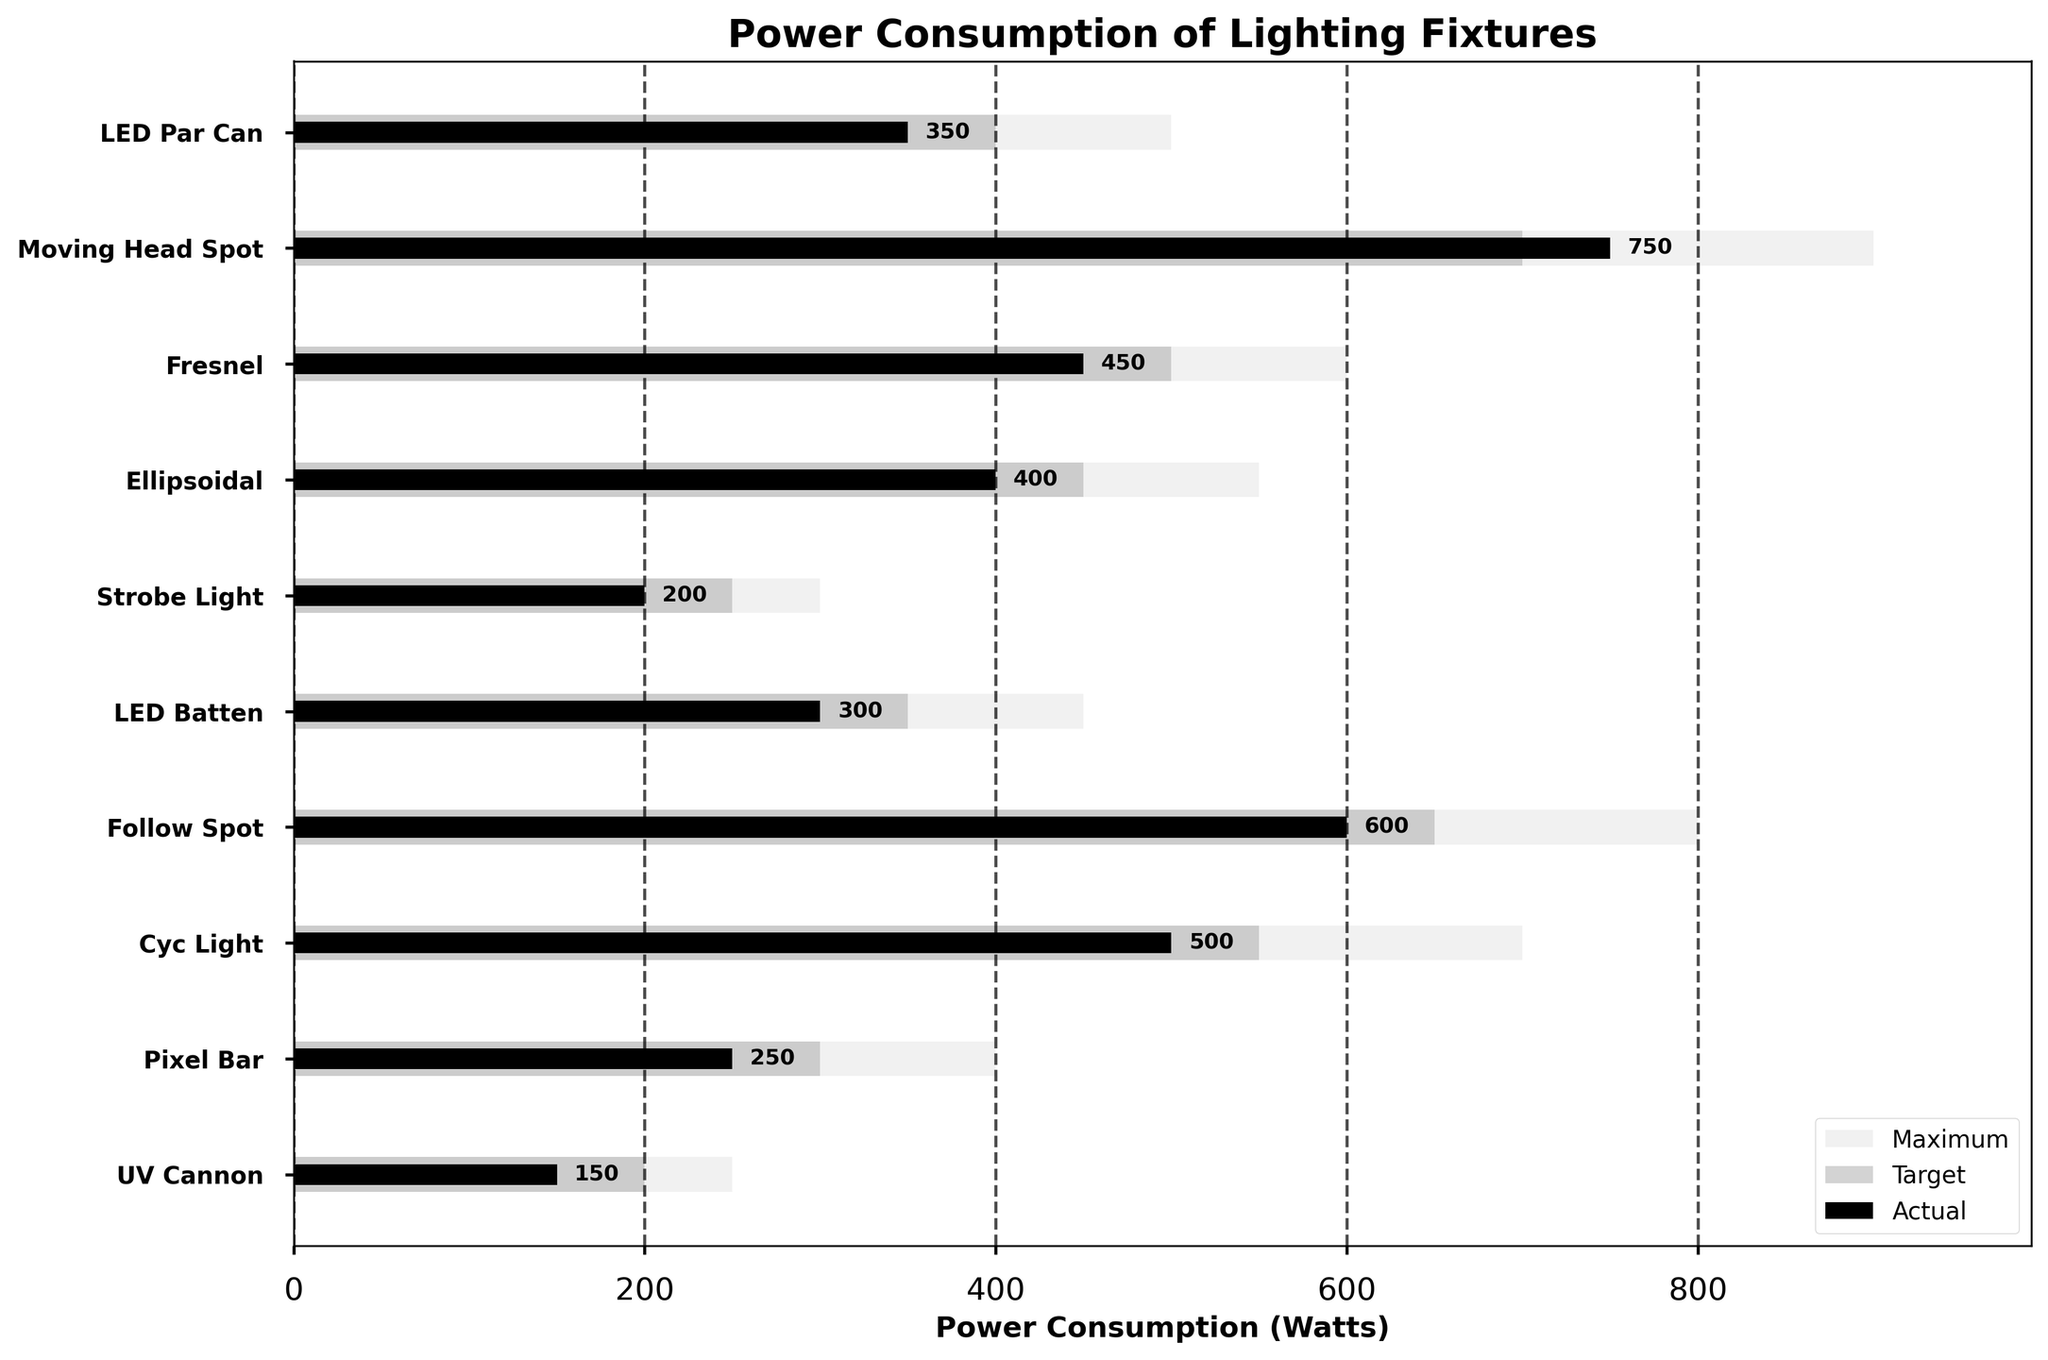how is the title of the chart? The title can be seen at the top of the figure which states "Power Consumption of Lighting Fixtures".
Answer: Power Consumption of Lighting Fixtures Which lighting fixture has the highest actual power consumption? The actual power consumption for each fixture is labeled in black. The Moving Head Spot has an actual power consumption of 750 Watts, which is the highest.
Answer: Moving Head Spot How many fixtures have an actual power consumption greater than their target power consumption? By comparing the black bars (actual) with the dark gray bars (target), we see that the Moving Head Spot, Follow Spot, and Pixel Bar have actual power consumption values greater than their target values.
Answer: 3 What is the range of power consumption for the Fresnel fixture? The range is determined by the maximum power consumption. For the Fresnel fixture, the maximum power consumption is 600 Watts.
Answer: 600 Watts Which lighting fixture's actual power consumption is closest to its target? By comparing the lengths of the black and dark gray bars, the Moving Head Spot's actual consumption (750 Watts) is only 50 Watts above its target (700 Watts), making it the closest.
Answer: Moving Head Spot What is the average actual power consumption of all fixtures? To find the average, add up all the actual values: 350 + 750 + 450 + 400 + 200 + 300 + 600 + 500 + 250 + 150 = 3950. Then, divide by the number of fixtures (10). The average is 3950/10 = 395 Watts.
Answer: 395 Watts Which fixture's actual power consumption is the least? By looking at the labels for the black bars, the UV Cannon has the lowest actual power consumption at 150 Watts.
Answer: UV Cannon How does the actual power consumption of the LED Batten compare to the Strobe Light? The actual power consumption of the LED Batten (300 Watts) is 100 Watts more than that of the Strobe Light (200 Watts).
Answer: 100 Watts more What percentage of the maximum power is the actual consumption for the Ellipsoidal fixture? The actual consumption is 400 Watts, and the maximum is 550 Watts. The percentage is calculated as (400/550) * 100 = approximately 72.73%.
Answer: 72.73% Are any fixtures under their target power consumption, and if so, which ones? By comparing the black bars (actual) with the dark gray bars (target), we observe that the LED Par Can, Fresnel, Ellipsoidal, Strobe Light, LED Batten, Cyc Light, and UV Cannon are under their target power consumption.
Answer: 7 Fixtures: LED Par Can, Fresnel, Ellipsoidal, Strobe Light, LED Batten, Cyc Light, UV Cannon 